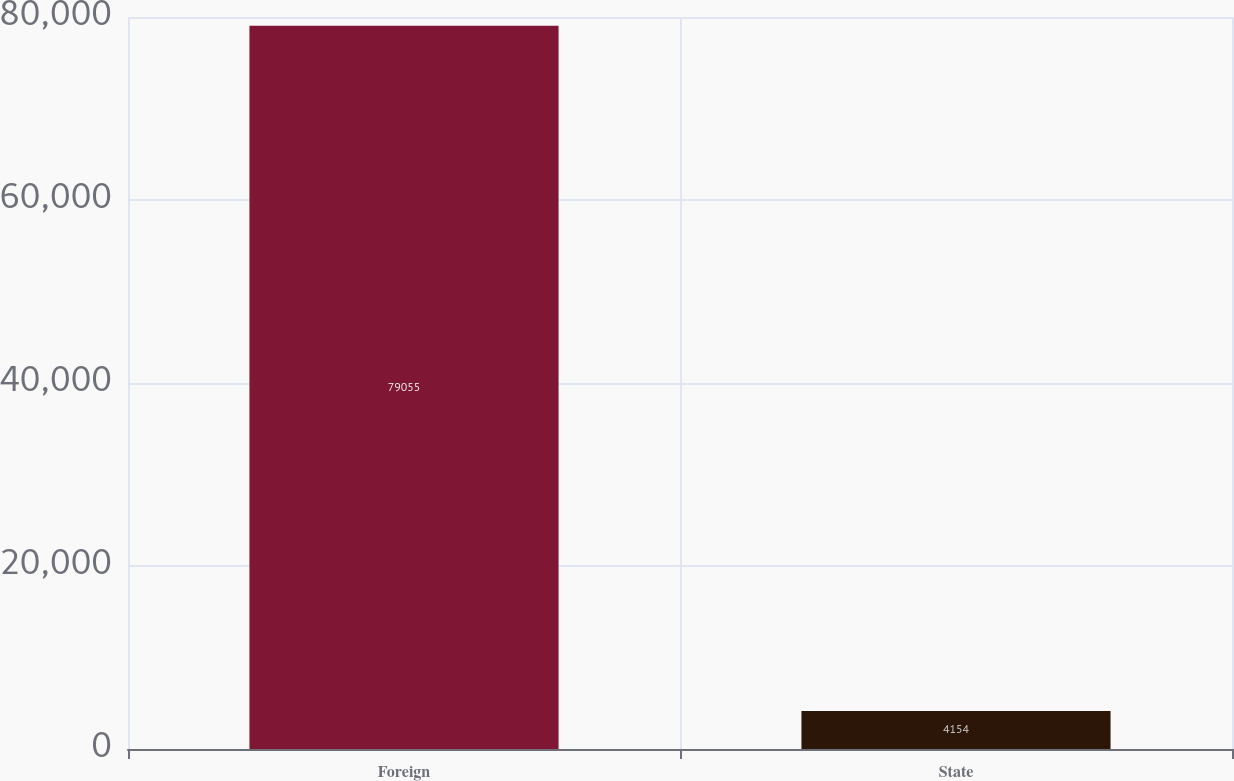Convert chart to OTSL. <chart><loc_0><loc_0><loc_500><loc_500><bar_chart><fcel>Foreign<fcel>State<nl><fcel>79055<fcel>4154<nl></chart> 